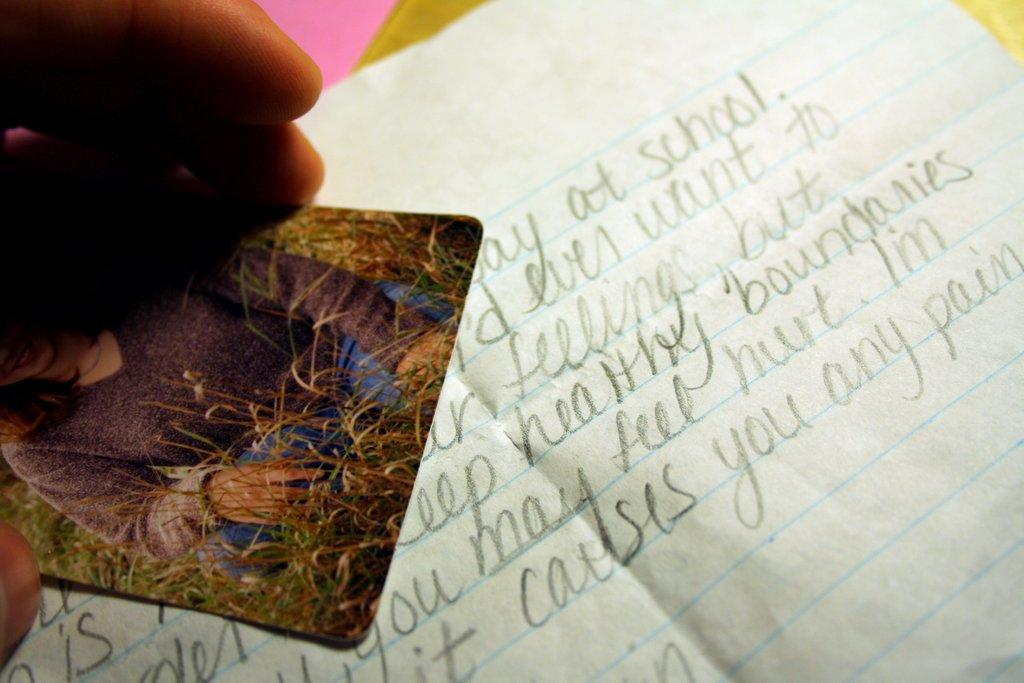What is the person in the image holding? The person is holding a photo in the image. What can be seen in the photo? The photo contains a picture of a woman, plants, and a paper with text. What is the purpose of the paper in the photo? The paper at the bottom of the photo has text on it, which may provide information or context about the photo. What month does the photo depict the woman in? The image does not provide information about the month or season in which the photo was taken. 